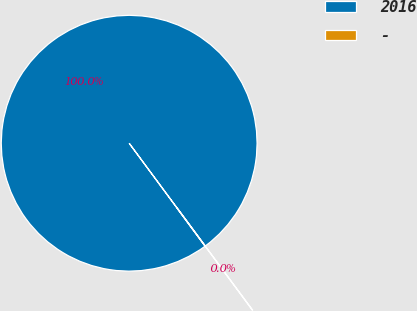Convert chart to OTSL. <chart><loc_0><loc_0><loc_500><loc_500><pie_chart><fcel>2016<fcel>-<nl><fcel>99.96%<fcel>0.04%<nl></chart> 